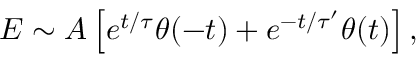<formula> <loc_0><loc_0><loc_500><loc_500>\begin{array} { r } { E \sim A \left [ e ^ { t / \tau } \theta ( - t ) + e ^ { - t / \tau ^ { \prime } } \theta ( t ) \right ] , } \end{array}</formula> 